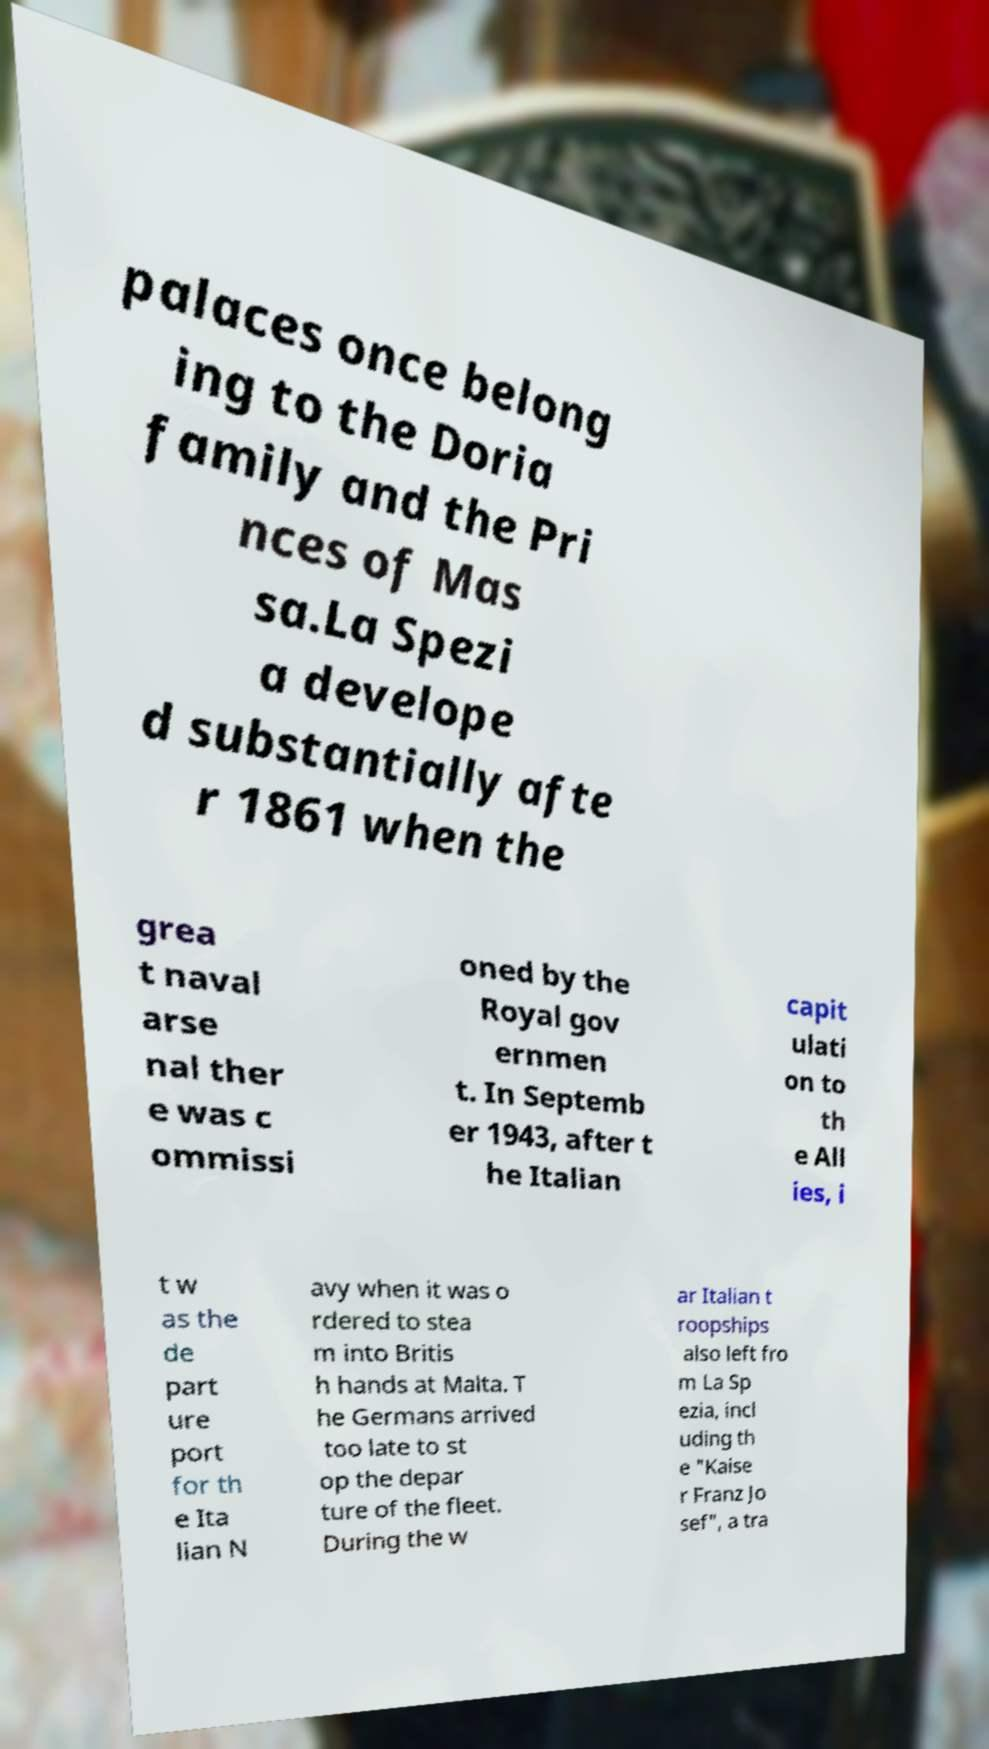Can you accurately transcribe the text from the provided image for me? palaces once belong ing to the Doria family and the Pri nces of Mas sa.La Spezi a develope d substantially afte r 1861 when the grea t naval arse nal ther e was c ommissi oned by the Royal gov ernmen t. In Septemb er 1943, after t he Italian capit ulati on to th e All ies, i t w as the de part ure port for th e Ita lian N avy when it was o rdered to stea m into Britis h hands at Malta. T he Germans arrived too late to st op the depar ture of the fleet. During the w ar Italian t roopships also left fro m La Sp ezia, incl uding th e "Kaise r Franz Jo sef", a tra 